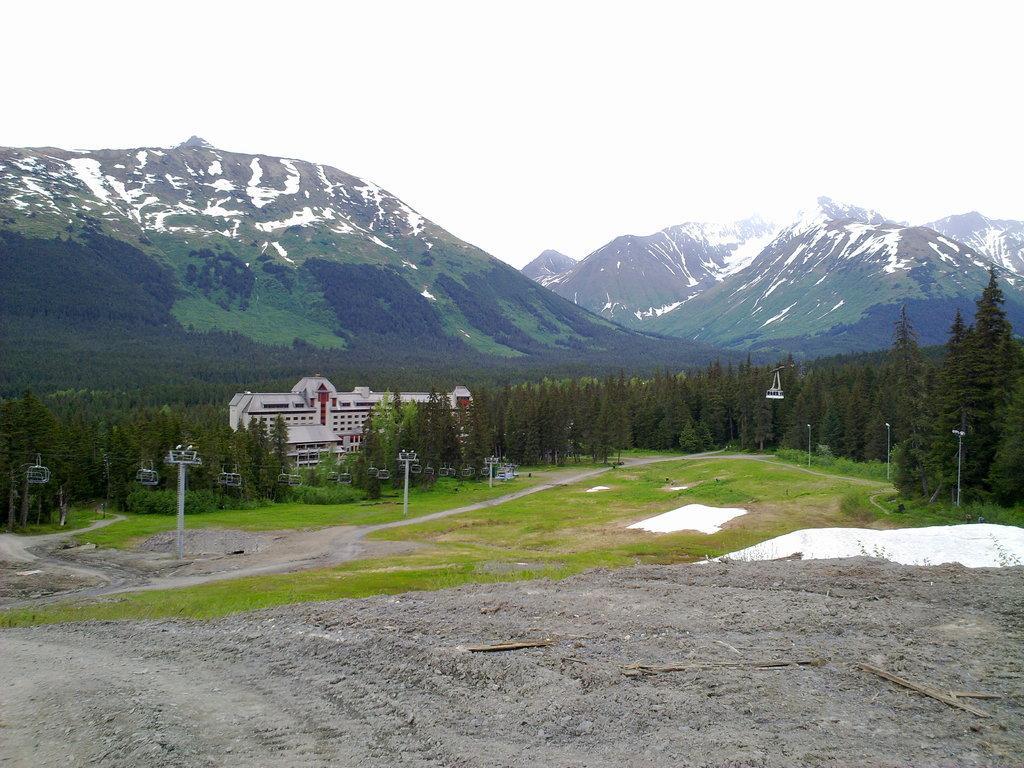Could you give a brief overview of what you see in this image? This image is taken outdoors. At the bottom of the image there is a ground with grass on it. In the background there are a few hills covered with snow. In the middle of the image there are many trees and plants and there are a few poles. There is a house. 